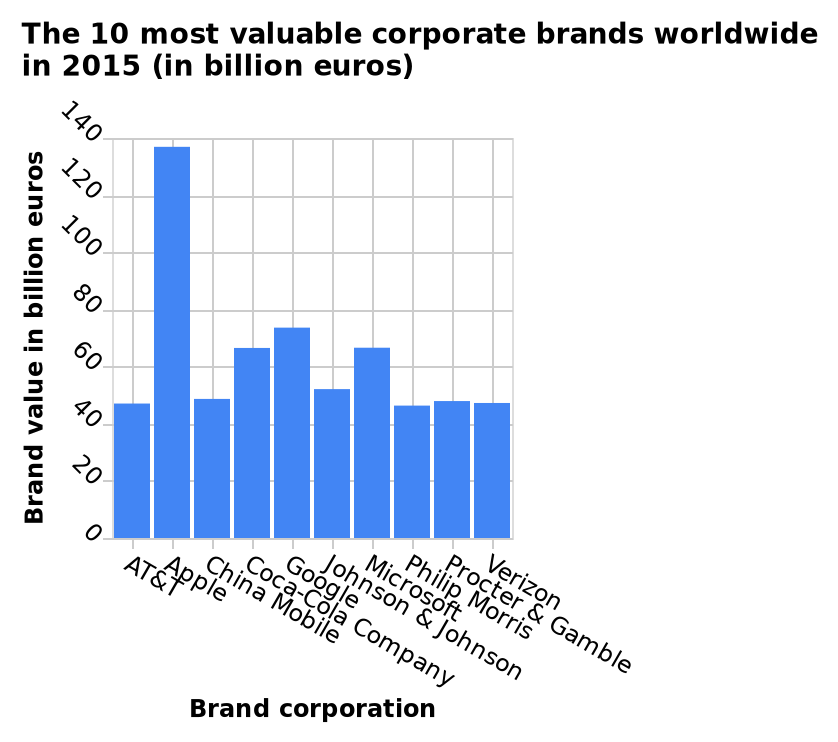<image>
What is the title of the bar diagram?  The 10 most valuable corporate brands worldwide in 2015 (in billion euros). please summary the statistics and relations of the chart Apple is the most valuable corporate brand worldwide at just under 140 billion euros. The second most valuable brand is google, far behind at just under 80 billion euros. Philip Morris is the least valuable brand out of the ones presented at just over 40 billion euros. 